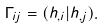Convert formula to latex. <formula><loc_0><loc_0><loc_500><loc_500>\Gamma _ { i j } = ( h _ { , i } | h _ { , j } ) .</formula> 